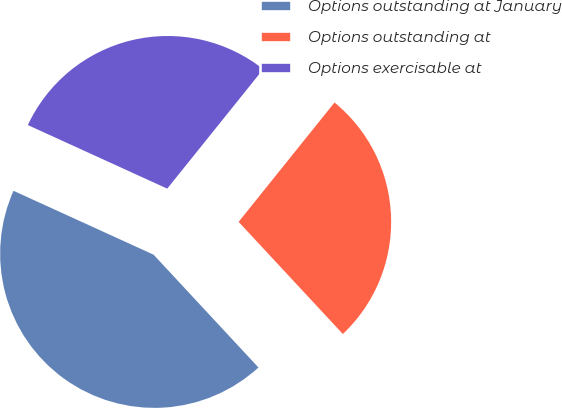<chart> <loc_0><loc_0><loc_500><loc_500><pie_chart><fcel>Options outstanding at January<fcel>Options outstanding at<fcel>Options exercisable at<nl><fcel>43.73%<fcel>27.31%<fcel>28.96%<nl></chart> 